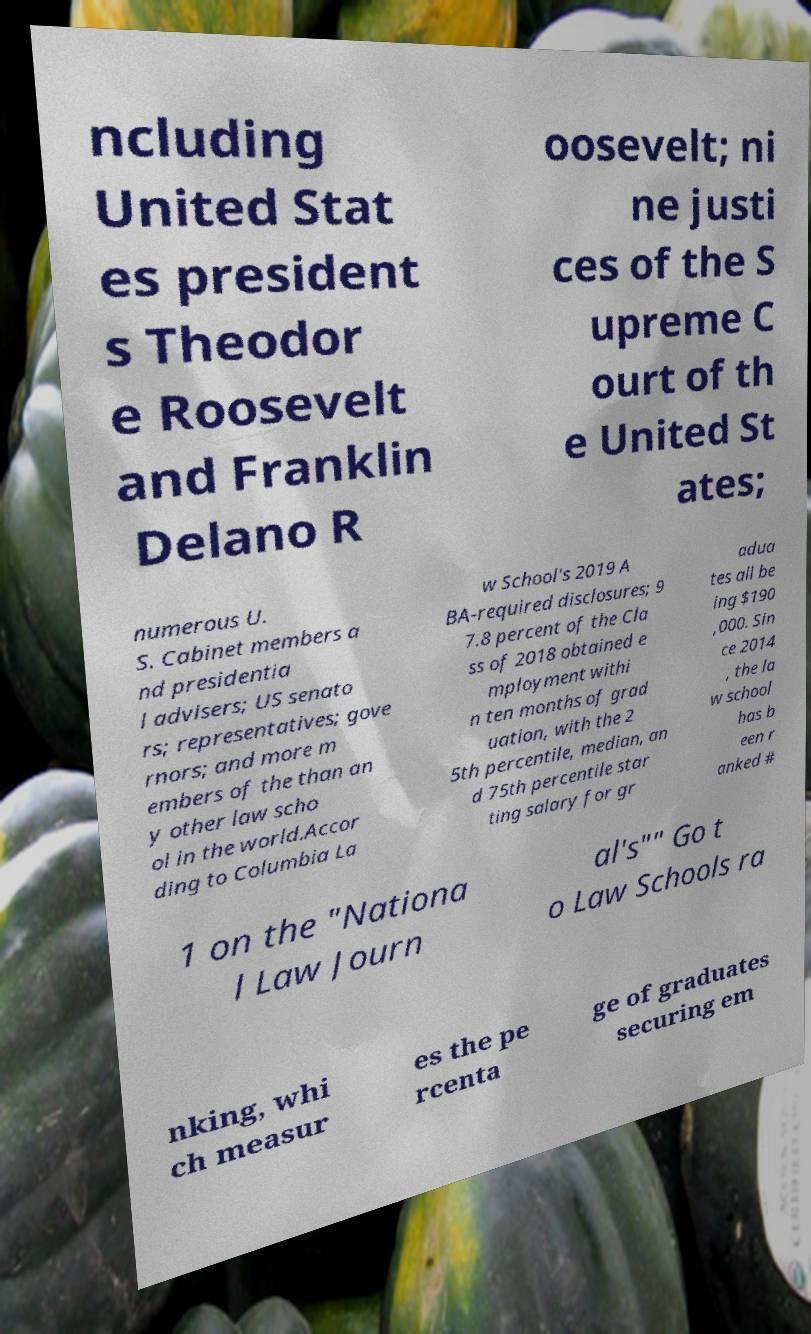What messages or text are displayed in this image? I need them in a readable, typed format. ncluding United Stat es president s Theodor e Roosevelt and Franklin Delano R oosevelt; ni ne justi ces of the S upreme C ourt of th e United St ates; numerous U. S. Cabinet members a nd presidentia l advisers; US senato rs; representatives; gove rnors; and more m embers of the than an y other law scho ol in the world.Accor ding to Columbia La w School's 2019 A BA-required disclosures; 9 7.8 percent of the Cla ss of 2018 obtained e mployment withi n ten months of grad uation, with the 2 5th percentile, median, an d 75th percentile star ting salary for gr adua tes all be ing $190 ,000. Sin ce 2014 , the la w school has b een r anked # 1 on the "Nationa l Law Journ al's"" Go t o Law Schools ra nking, whi ch measur es the pe rcenta ge of graduates securing em 